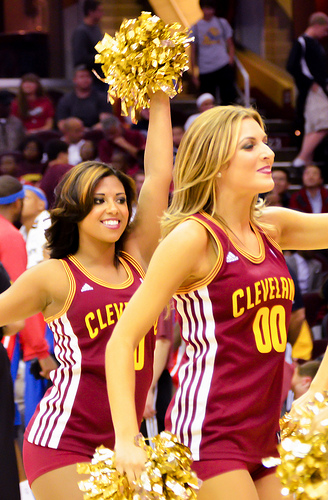<image>
Is there a girl on the girl? No. The girl is not positioned on the girl. They may be near each other, but the girl is not supported by or resting on top of the girl. Where is the cheerleader in relation to the cheerleader? Is it in front of the cheerleader? Yes. The cheerleader is positioned in front of the cheerleader, appearing closer to the camera viewpoint. 